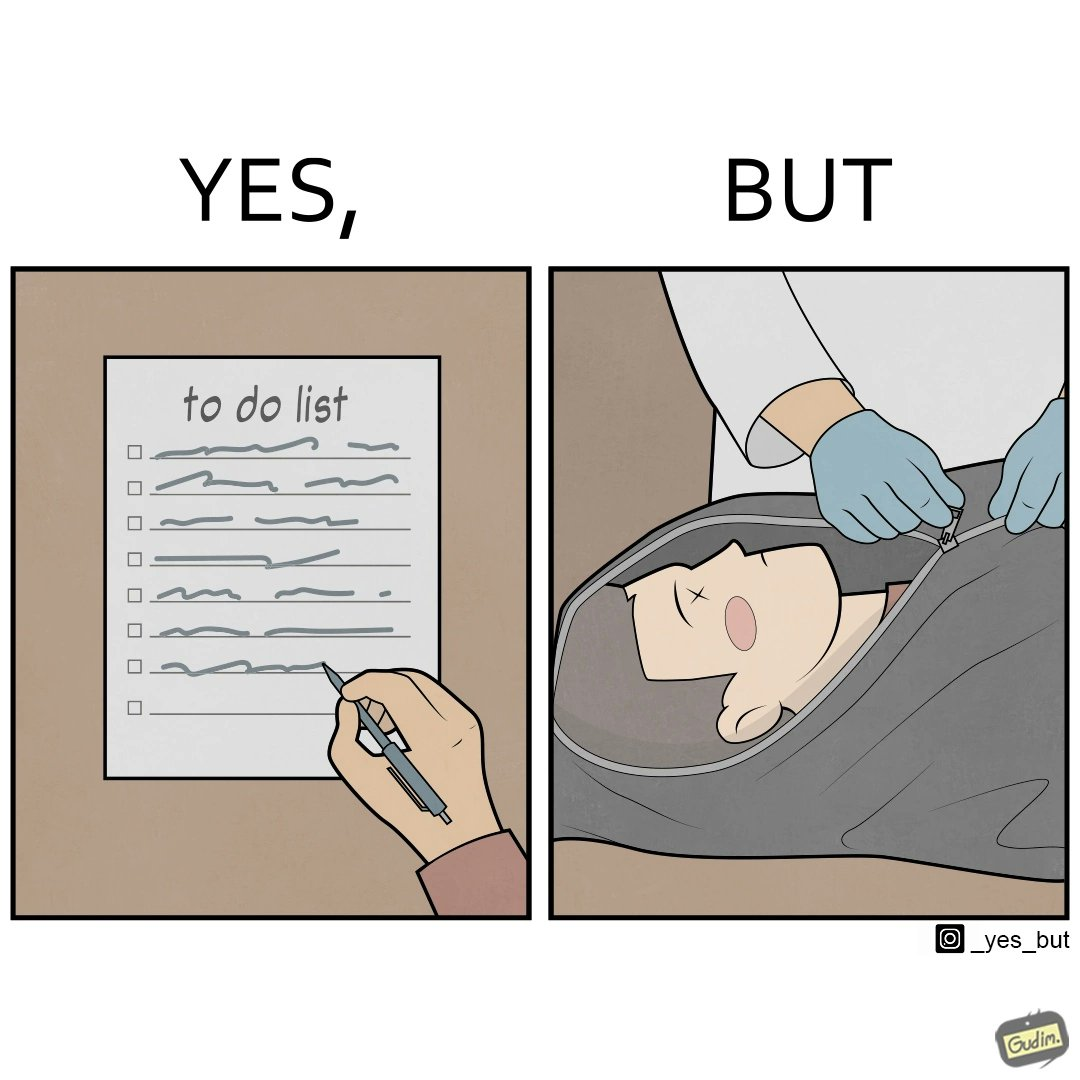What is shown in the left half versus the right half of this image? In the left part of the image: a person writing his/her to-do list In the right part of the image: a person zipping a dead body inside some cover 